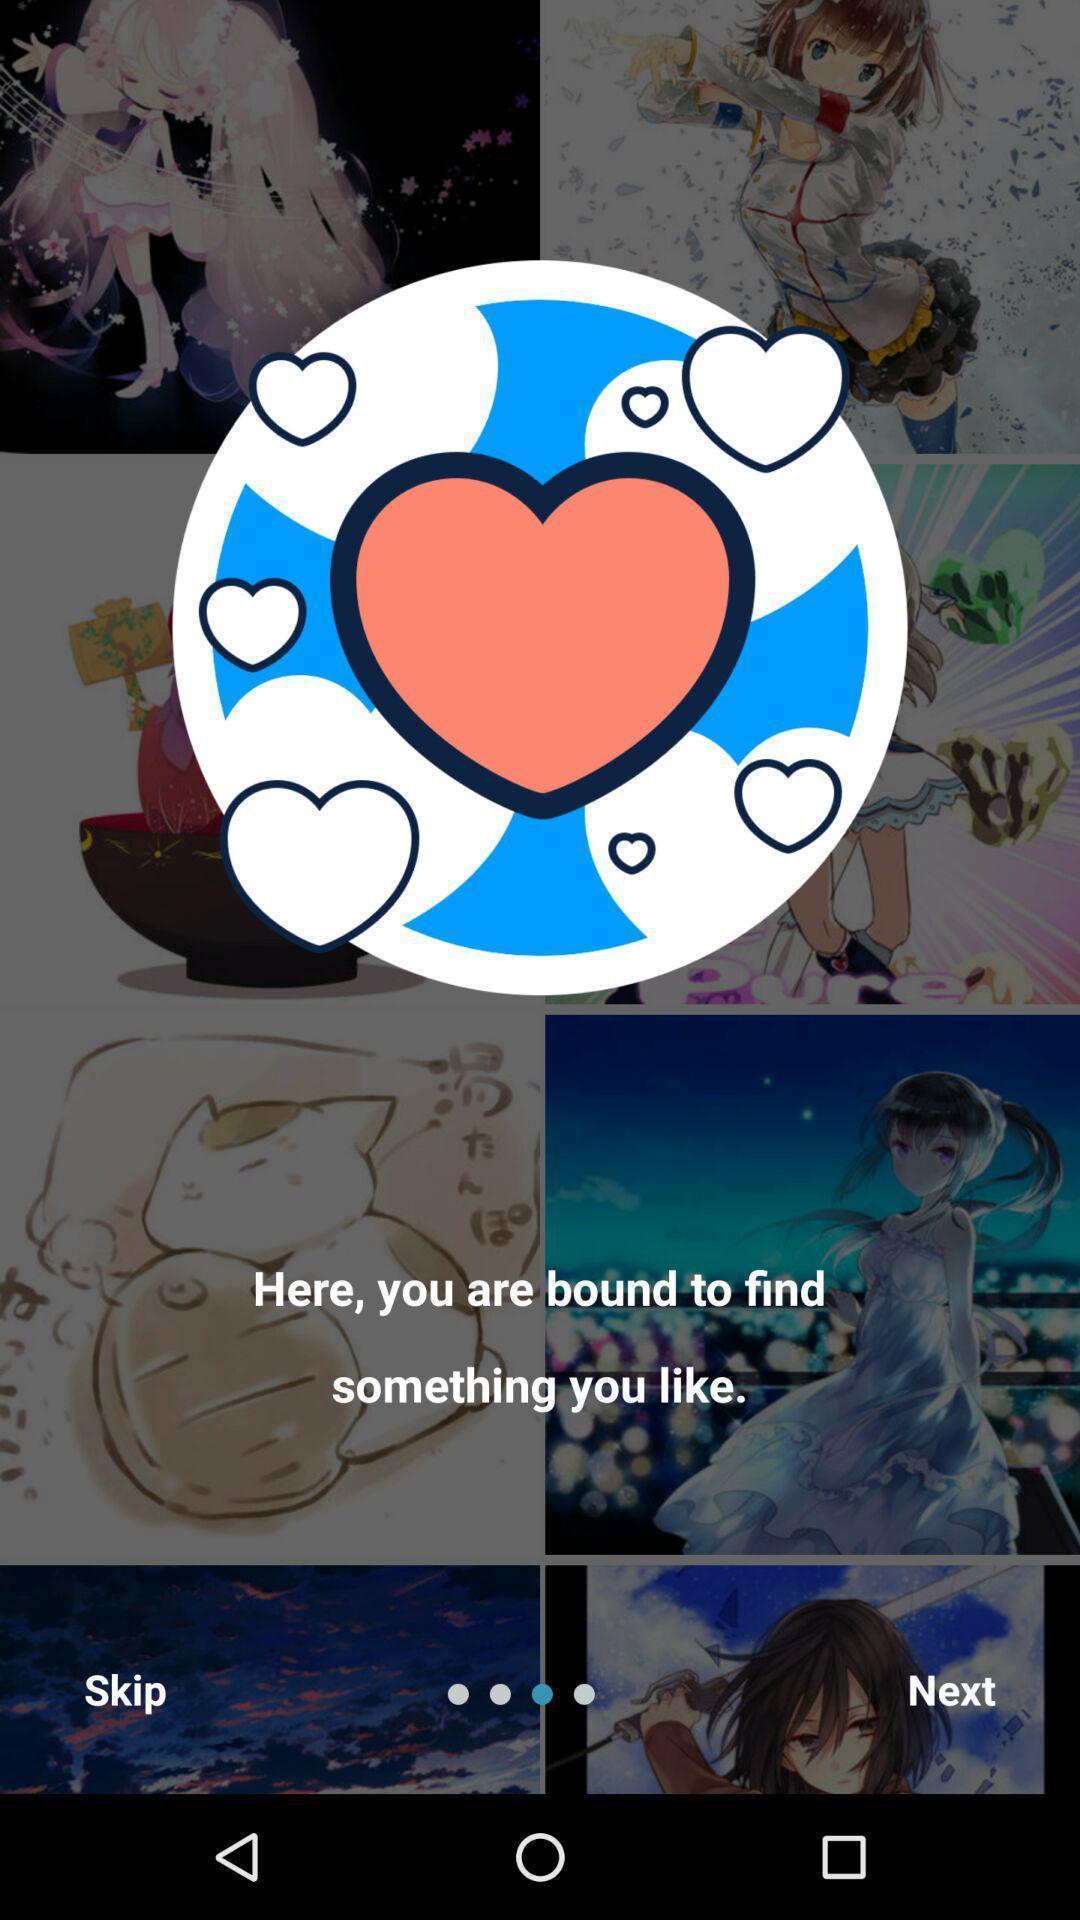Describe the key features of this screenshot. Page displaying information about an online community for artist application. 